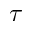Convert formula to latex. <formula><loc_0><loc_0><loc_500><loc_500>\tau</formula> 